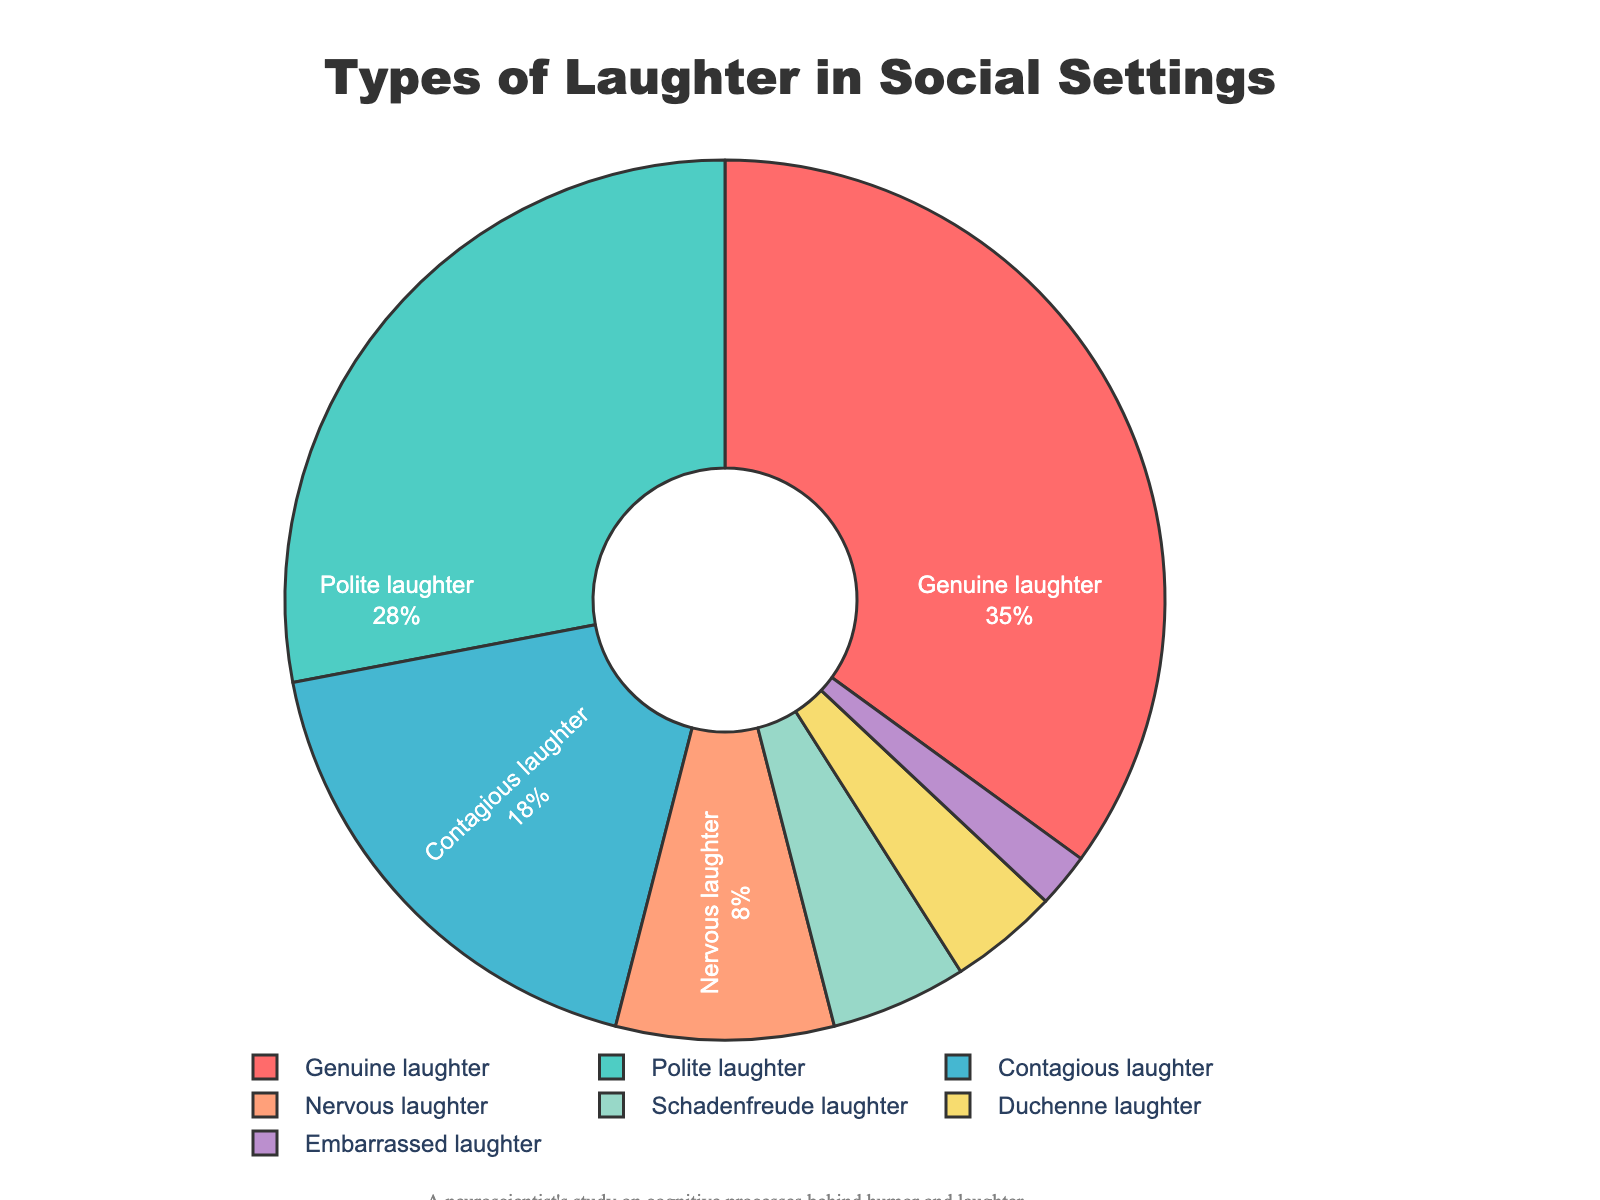What's the most commonly observed type of laughter in the social settings? By examining the largest segment of the pie chart and its accompanying label, it's clear that Genuine laughter has the highest percentage.
Answer: Genuine laughter Which type of laughter is observed more frequently: Polite laughter or Contagious laughter? By comparing the sizes of the segments and their labels, Polite laughter (28%) is observed more frequently than Contagious laughter (18%).
Answer: Polite laughter What is the combined percentage of Contagious laughter and Nervous laughter? By summing the percentages for Contagious laughter (18%) and Nervous laughter (8%), we get 18 + 8 = 26%.
Answer: 26% Between Schadenfreude laughter and Duchenne laughter, which is observed less frequently? By comparing the percentages, Schadenfreude laughter (5%) is observed more frequently than Duchenne laughter (4%). Thus, Duchenne laughter is less frequent.
Answer: Duchenne laughter How much more frequent is Genuine laughter compared to Embarrassed laughter? Genuine laughter (35%) minus Embarrassed laughter (2%) equals 33%. So, Genuine laughter is 33% more frequent than Embarrassed laughter.
Answer: 33% Describe the color associated with Polite laughter. By examining the pie chart, Polite laughter is represented by the green-colored segment.
Answer: Green What is the total percentage of all types of laughter that account for less than 10% individually? Summing the percentages for Nervous laughter (8%), Schadenfreude laughter (5%), Duchenne laughter (4%), and Embarrassed laughter (2%) gives us 8 + 5 + 4 + 2 = 19%.
Answer: 19% Which laughter type has the second highest proportion in the chart? The second largest segment by percentage is Polite laughter at 28%, right after Genuine laughter.
Answer: Polite laughter What is the difference in percentage between the most and least frequent types of laughter? The most frequent type of laughter is Genuine laughter (35%) and the least frequent is Embarrassed laughter (2%). The difference is 35 - 2 = 33%.
Answer: 33% 